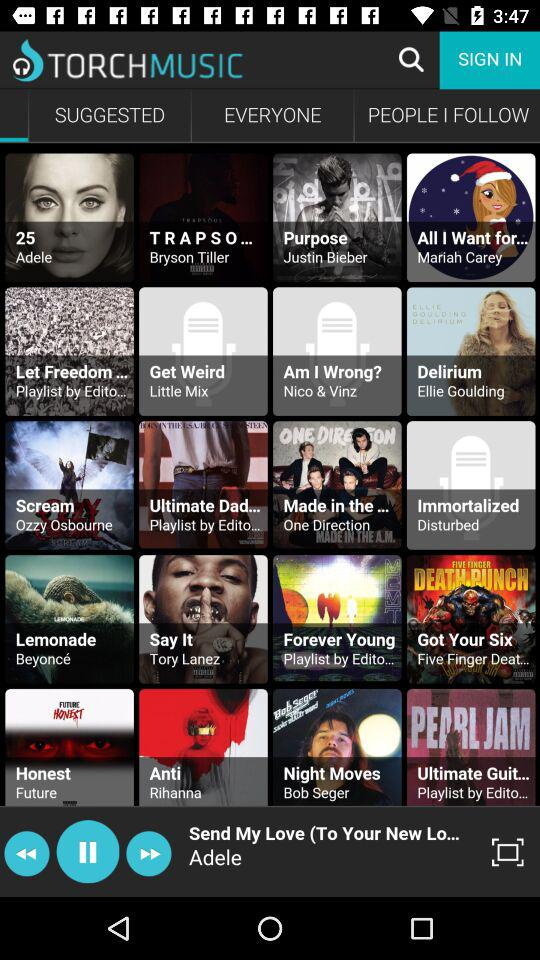Which are the suggested albums?
When the provided information is insufficient, respond with <no answer>. <no answer> 